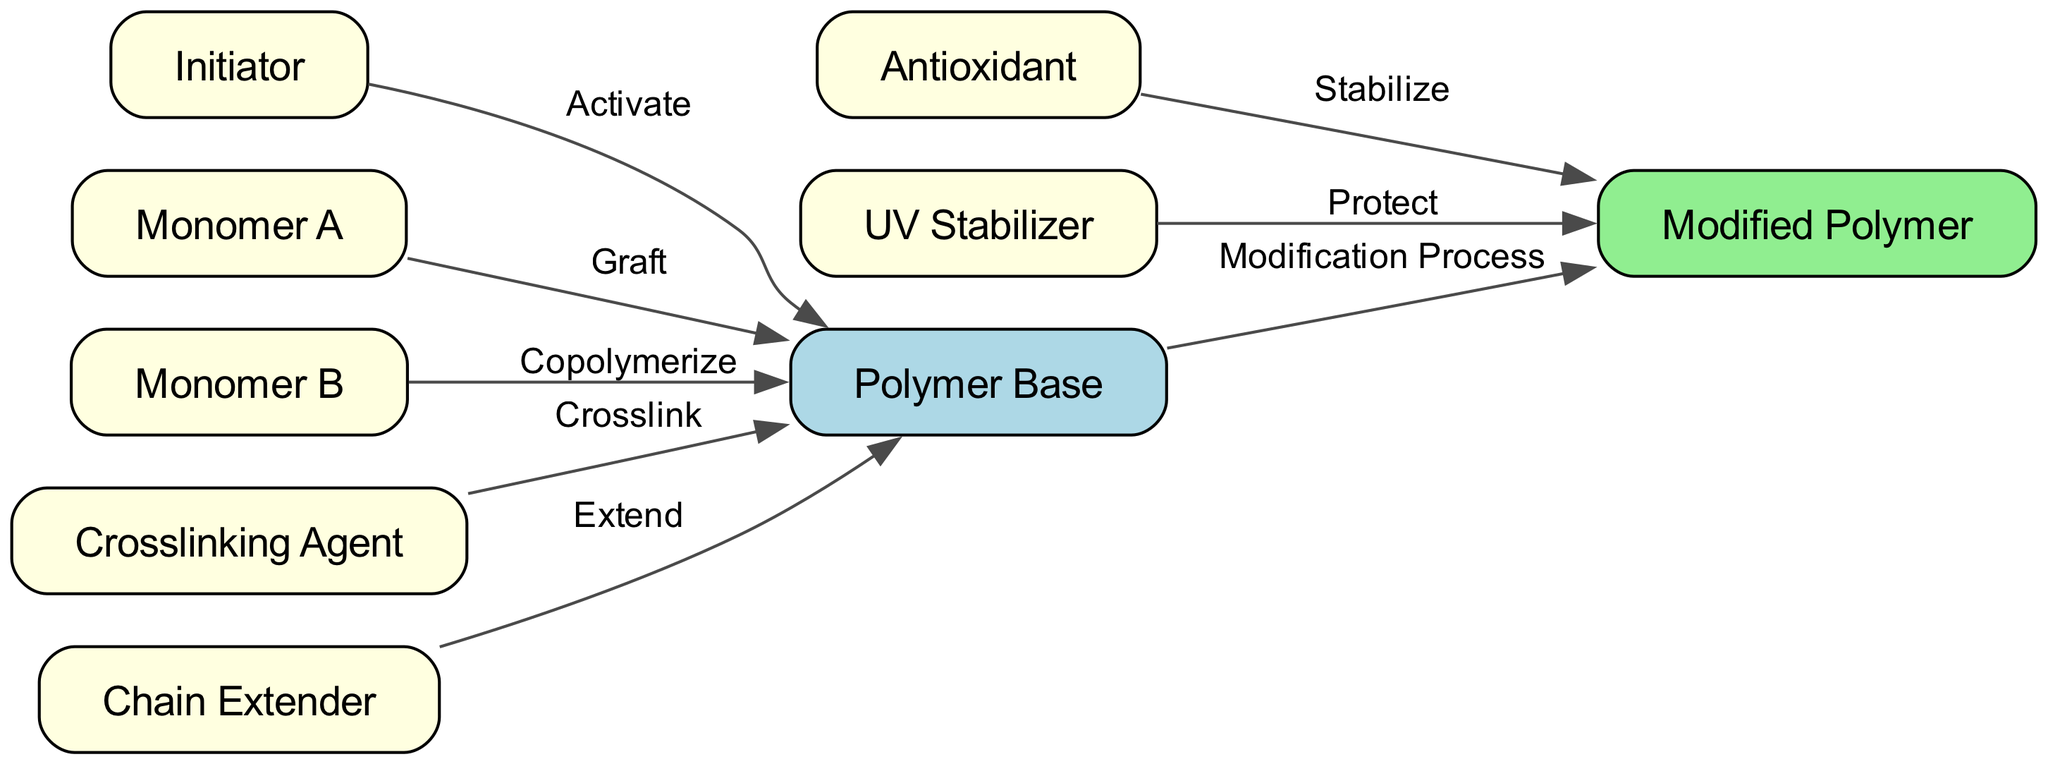What is the initial node in the diagram? The initial node, often representing the starting point of the polymer modification process, is indicated as "Polymer Base" in the diagram.
Answer: Polymer Base How many total nodes are present in the diagram? By counting the nodes listed in the diagram, we find there are 9 distinct nodes: Polymer Base, Initiator, Monomer A, Monomer B, Crosslinking Agent, Chain Extender, Antioxidant, UV Stabilizer, and Modified Polymer.
Answer: 9 Which agent is used to crosslink the polymer? The diagram shows the "Crosslinking Agent" as the specific agent responsible for the crosslinking process with respect to the Polymer Base.
Answer: Crosslinking Agent What actions relate to the Polymer Base? The Polymer Base has multiple relationships or actions: it is activated by an Initiator, grafted by Monomer A, copolymerized with Monomer B, crossed with a Crosslinking Agent, and extended by a Chain Extender.
Answer: Activate, Graft, Copolymerize, Crosslink, Extend Which two agents contribute to the stabilization of the Modified Polymer? The diagram clearly indicates that both "Antioxidant" and "UV Stabilizer" directly interact with the "Modified Polymer" to provide stabilization and protection respectively.
Answer: Antioxidant, UV Stabilizer How many edges point towards the Modified Polymer? By examining the diagram, there are 2 edges that point towards the Modified Polymer: one from Antioxidant and one from UV Stabilizer.
Answer: 2 What is the relationship between Monomer A and the Polymer Base? The relationship between Monomer A and the Polymer Base is defined as "Graft," indicating that Monomer A is used to modify the polymer through this specific process.
Answer: Graft Which node is colored light green? In the diagram, the node representing the "Modified Polymer" is uniquely colored light green, distinguishing it from other nodes.
Answer: Modified Polymer Which node activates the Polymer Base? The "Initiator" node is the one that activates the Polymer Base, as indicated by the directed edge leading from Initiator to Polymer Base labeled "Activate."
Answer: Initiator 